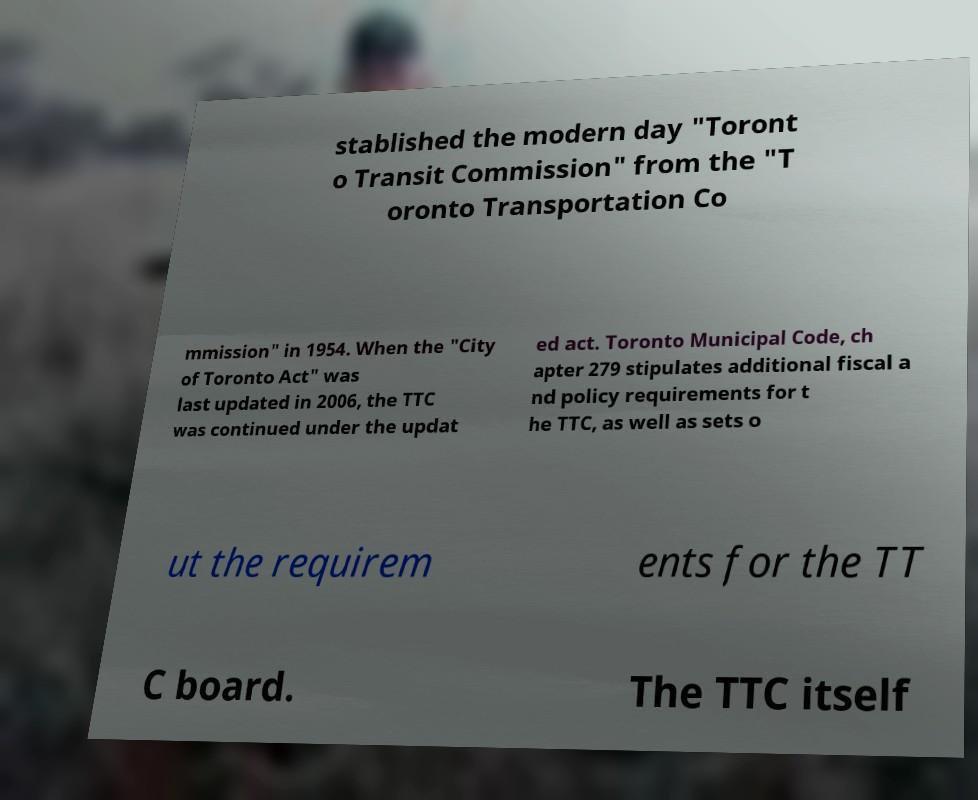Can you read and provide the text displayed in the image?This photo seems to have some interesting text. Can you extract and type it out for me? stablished the modern day "Toront o Transit Commission" from the "T oronto Transportation Co mmission" in 1954. When the "City of Toronto Act" was last updated in 2006, the TTC was continued under the updat ed act. Toronto Municipal Code, ch apter 279 stipulates additional fiscal a nd policy requirements for t he TTC, as well as sets o ut the requirem ents for the TT C board. The TTC itself 